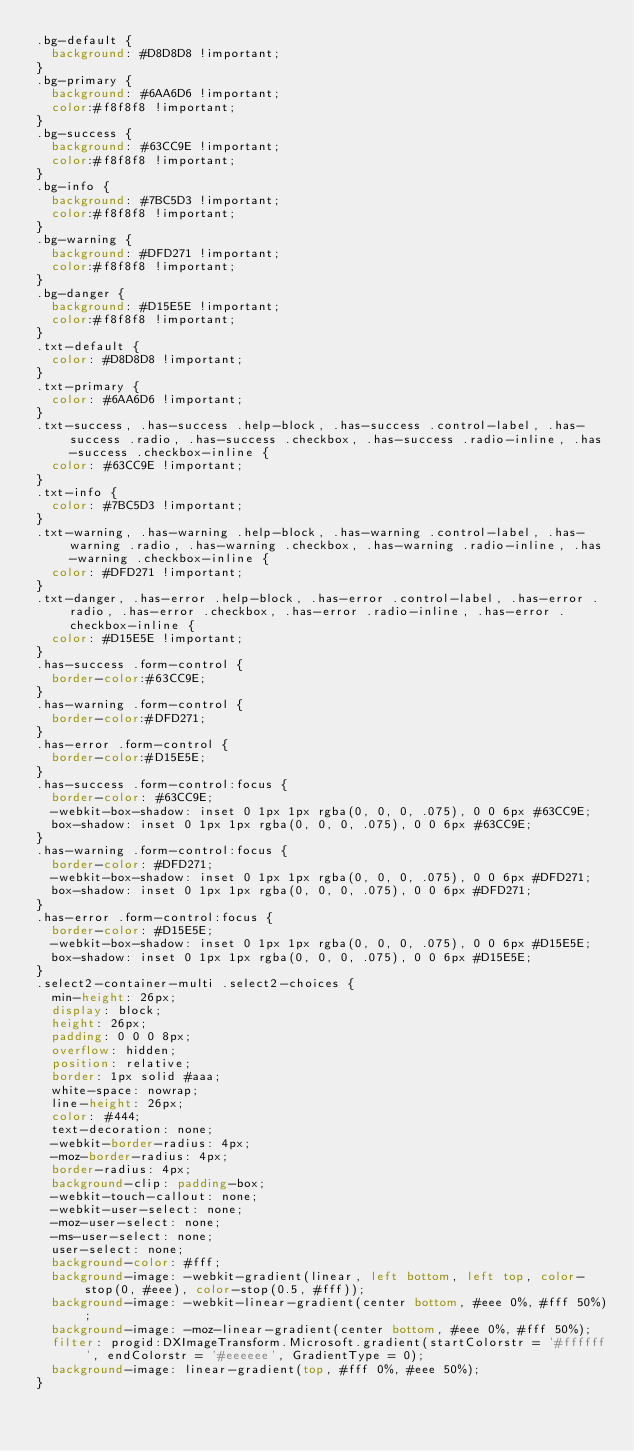<code> <loc_0><loc_0><loc_500><loc_500><_CSS_>.bg-default {
  background: #D8D8D8 !important;
}
.bg-primary {
  background: #6AA6D6 !important;
  color:#f8f8f8 !important;
}
.bg-success {
  background: #63CC9E !important;
  color:#f8f8f8 !important;
}
.bg-info {
  background: #7BC5D3 !important;
  color:#f8f8f8 !important;
}
.bg-warning {
  background: #DFD271 !important;
  color:#f8f8f8 !important;
}
.bg-danger {
  background: #D15E5E !important;
  color:#f8f8f8 !important;
}
.txt-default {
  color: #D8D8D8 !important;
}
.txt-primary {
  color: #6AA6D6 !important;
}
.txt-success, .has-success .help-block, .has-success .control-label, .has-success .radio, .has-success .checkbox, .has-success .radio-inline, .has-success .checkbox-inline {
  color: #63CC9E !important;
}
.txt-info {
  color: #7BC5D3 !important;
}
.txt-warning, .has-warning .help-block, .has-warning .control-label, .has-warning .radio, .has-warning .checkbox, .has-warning .radio-inline, .has-warning .checkbox-inline {
  color: #DFD271 !important;
}
.txt-danger, .has-error .help-block, .has-error .control-label, .has-error .radio, .has-error .checkbox, .has-error .radio-inline, .has-error .checkbox-inline {
  color: #D15E5E !important;
}
.has-success .form-control {
  border-color:#63CC9E;
}
.has-warning .form-control {
  border-color:#DFD271;
}
.has-error .form-control {
  border-color:#D15E5E;
}
.has-success .form-control:focus {
  border-color: #63CC9E;
  -webkit-box-shadow: inset 0 1px 1px rgba(0, 0, 0, .075), 0 0 6px #63CC9E;
  box-shadow: inset 0 1px 1px rgba(0, 0, 0, .075), 0 0 6px #63CC9E;
}
.has-warning .form-control:focus {
  border-color: #DFD271;
  -webkit-box-shadow: inset 0 1px 1px rgba(0, 0, 0, .075), 0 0 6px #DFD271;
  box-shadow: inset 0 1px 1px rgba(0, 0, 0, .075), 0 0 6px #DFD271;
}
.has-error .form-control:focus {
  border-color: #D15E5E;
  -webkit-box-shadow: inset 0 1px 1px rgba(0, 0, 0, .075), 0 0 6px #D15E5E;
  box-shadow: inset 0 1px 1px rgba(0, 0, 0, .075), 0 0 6px #D15E5E;
}
.select2-container-multi .select2-choices {
  min-height: 26px;
  display: block;
  height: 26px;
  padding: 0 0 0 8px;
  overflow: hidden;
  position: relative;
  border: 1px solid #aaa;
  white-space: nowrap;
  line-height: 26px;
  color: #444;
  text-decoration: none;
  -webkit-border-radius: 4px;
  -moz-border-radius: 4px;
  border-radius: 4px;
  background-clip: padding-box;
  -webkit-touch-callout: none;
  -webkit-user-select: none;
  -moz-user-select: none;
  -ms-user-select: none;
  user-select: none;
  background-color: #fff;
  background-image: -webkit-gradient(linear, left bottom, left top, color-stop(0, #eee), color-stop(0.5, #fff));
  background-image: -webkit-linear-gradient(center bottom, #eee 0%, #fff 50%);
  background-image: -moz-linear-gradient(center bottom, #eee 0%, #fff 50%);
  filter: progid:DXImageTransform.Microsoft.gradient(startColorstr = '#ffffff', endColorstr = '#eeeeee', GradientType = 0);
  background-image: linear-gradient(top, #fff 0%, #eee 50%);
}</code> 